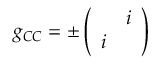<formula> <loc_0><loc_0><loc_500><loc_500>g _ { C C } = \pm \left ( \begin{array} { c c & { i } \\ { i } \end{array} \right )</formula> 